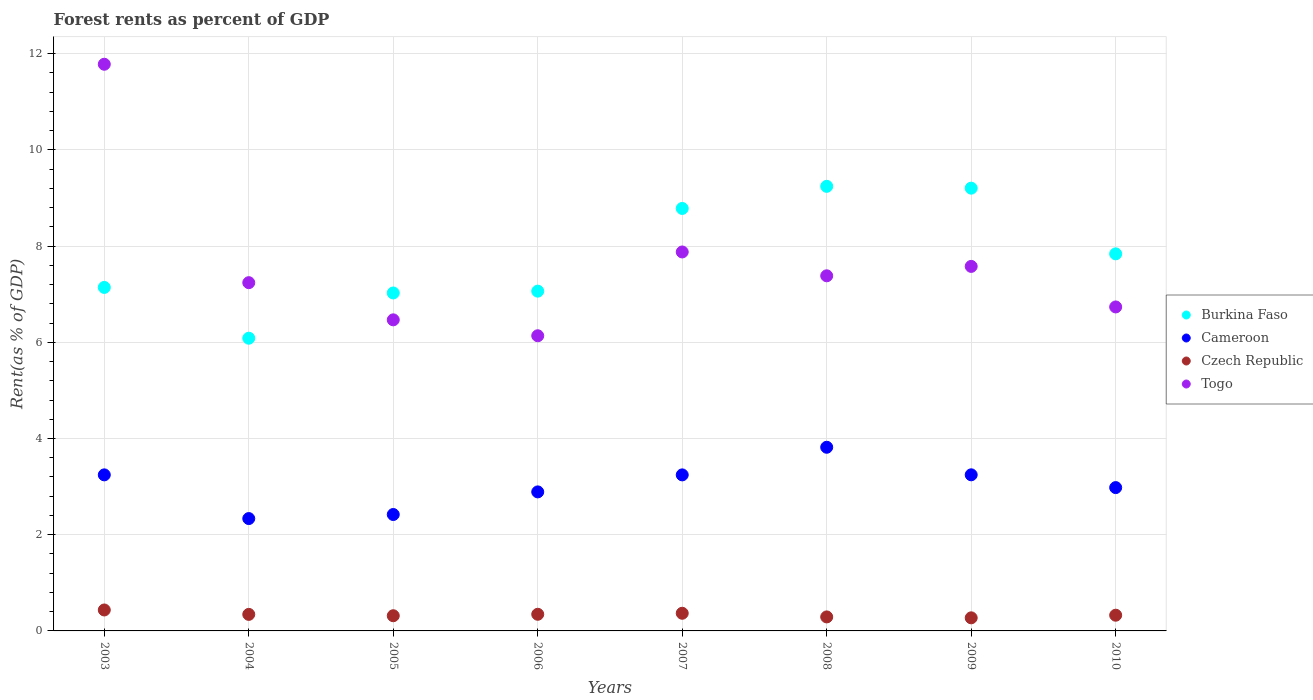What is the forest rent in Togo in 2009?
Provide a short and direct response. 7.58. Across all years, what is the maximum forest rent in Togo?
Your answer should be compact. 11.78. Across all years, what is the minimum forest rent in Cameroon?
Offer a very short reply. 2.34. What is the total forest rent in Togo in the graph?
Keep it short and to the point. 61.2. What is the difference between the forest rent in Cameroon in 2003 and that in 2005?
Ensure brevity in your answer.  0.82. What is the difference between the forest rent in Burkina Faso in 2006 and the forest rent in Cameroon in 2008?
Your response must be concise. 3.25. What is the average forest rent in Czech Republic per year?
Your answer should be compact. 0.34. In the year 2007, what is the difference between the forest rent in Czech Republic and forest rent in Cameroon?
Your response must be concise. -2.88. In how many years, is the forest rent in Burkina Faso greater than 0.4 %?
Provide a short and direct response. 8. What is the ratio of the forest rent in Togo in 2006 to that in 2008?
Provide a short and direct response. 0.83. Is the forest rent in Burkina Faso in 2004 less than that in 2007?
Provide a succinct answer. Yes. Is the difference between the forest rent in Czech Republic in 2006 and 2008 greater than the difference between the forest rent in Cameroon in 2006 and 2008?
Keep it short and to the point. Yes. What is the difference between the highest and the second highest forest rent in Togo?
Your answer should be compact. 3.9. What is the difference between the highest and the lowest forest rent in Togo?
Your answer should be very brief. 5.64. In how many years, is the forest rent in Burkina Faso greater than the average forest rent in Burkina Faso taken over all years?
Keep it short and to the point. 4. Is it the case that in every year, the sum of the forest rent in Burkina Faso and forest rent in Cameroon  is greater than the sum of forest rent in Togo and forest rent in Czech Republic?
Ensure brevity in your answer.  Yes. Is the forest rent in Cameroon strictly less than the forest rent in Czech Republic over the years?
Offer a very short reply. No. How many dotlines are there?
Your response must be concise. 4. What is the difference between two consecutive major ticks on the Y-axis?
Provide a short and direct response. 2. Does the graph contain grids?
Your answer should be compact. Yes. How many legend labels are there?
Make the answer very short. 4. What is the title of the graph?
Your answer should be very brief. Forest rents as percent of GDP. Does "Cote d'Ivoire" appear as one of the legend labels in the graph?
Give a very brief answer. No. What is the label or title of the Y-axis?
Offer a terse response. Rent(as % of GDP). What is the Rent(as % of GDP) of Burkina Faso in 2003?
Your answer should be very brief. 7.14. What is the Rent(as % of GDP) of Cameroon in 2003?
Provide a succinct answer. 3.24. What is the Rent(as % of GDP) in Czech Republic in 2003?
Your answer should be very brief. 0.44. What is the Rent(as % of GDP) of Togo in 2003?
Your answer should be compact. 11.78. What is the Rent(as % of GDP) in Burkina Faso in 2004?
Provide a short and direct response. 6.09. What is the Rent(as % of GDP) of Cameroon in 2004?
Provide a succinct answer. 2.34. What is the Rent(as % of GDP) of Czech Republic in 2004?
Your response must be concise. 0.34. What is the Rent(as % of GDP) in Togo in 2004?
Your answer should be compact. 7.24. What is the Rent(as % of GDP) in Burkina Faso in 2005?
Provide a short and direct response. 7.03. What is the Rent(as % of GDP) of Cameroon in 2005?
Make the answer very short. 2.42. What is the Rent(as % of GDP) in Czech Republic in 2005?
Offer a very short reply. 0.32. What is the Rent(as % of GDP) of Togo in 2005?
Provide a short and direct response. 6.47. What is the Rent(as % of GDP) of Burkina Faso in 2006?
Give a very brief answer. 7.06. What is the Rent(as % of GDP) of Cameroon in 2006?
Provide a succinct answer. 2.89. What is the Rent(as % of GDP) in Czech Republic in 2006?
Give a very brief answer. 0.35. What is the Rent(as % of GDP) in Togo in 2006?
Keep it short and to the point. 6.14. What is the Rent(as % of GDP) in Burkina Faso in 2007?
Offer a very short reply. 8.78. What is the Rent(as % of GDP) in Cameroon in 2007?
Provide a succinct answer. 3.24. What is the Rent(as % of GDP) in Czech Republic in 2007?
Ensure brevity in your answer.  0.37. What is the Rent(as % of GDP) in Togo in 2007?
Offer a very short reply. 7.88. What is the Rent(as % of GDP) of Burkina Faso in 2008?
Keep it short and to the point. 9.24. What is the Rent(as % of GDP) of Cameroon in 2008?
Provide a short and direct response. 3.82. What is the Rent(as % of GDP) in Czech Republic in 2008?
Your answer should be compact. 0.29. What is the Rent(as % of GDP) in Togo in 2008?
Give a very brief answer. 7.38. What is the Rent(as % of GDP) in Burkina Faso in 2009?
Provide a short and direct response. 9.2. What is the Rent(as % of GDP) in Cameroon in 2009?
Your response must be concise. 3.25. What is the Rent(as % of GDP) of Czech Republic in 2009?
Keep it short and to the point. 0.27. What is the Rent(as % of GDP) in Togo in 2009?
Give a very brief answer. 7.58. What is the Rent(as % of GDP) of Burkina Faso in 2010?
Provide a succinct answer. 7.84. What is the Rent(as % of GDP) of Cameroon in 2010?
Keep it short and to the point. 2.98. What is the Rent(as % of GDP) of Czech Republic in 2010?
Provide a short and direct response. 0.33. What is the Rent(as % of GDP) in Togo in 2010?
Give a very brief answer. 6.74. Across all years, what is the maximum Rent(as % of GDP) in Burkina Faso?
Keep it short and to the point. 9.24. Across all years, what is the maximum Rent(as % of GDP) of Cameroon?
Your answer should be compact. 3.82. Across all years, what is the maximum Rent(as % of GDP) of Czech Republic?
Your answer should be compact. 0.44. Across all years, what is the maximum Rent(as % of GDP) of Togo?
Your answer should be compact. 11.78. Across all years, what is the minimum Rent(as % of GDP) of Burkina Faso?
Provide a short and direct response. 6.09. Across all years, what is the minimum Rent(as % of GDP) in Cameroon?
Give a very brief answer. 2.34. Across all years, what is the minimum Rent(as % of GDP) in Czech Republic?
Make the answer very short. 0.27. Across all years, what is the minimum Rent(as % of GDP) of Togo?
Your answer should be very brief. 6.14. What is the total Rent(as % of GDP) in Burkina Faso in the graph?
Provide a succinct answer. 62.38. What is the total Rent(as % of GDP) in Cameroon in the graph?
Offer a very short reply. 24.18. What is the total Rent(as % of GDP) in Czech Republic in the graph?
Your answer should be compact. 2.7. What is the total Rent(as % of GDP) in Togo in the graph?
Ensure brevity in your answer.  61.2. What is the difference between the Rent(as % of GDP) of Burkina Faso in 2003 and that in 2004?
Make the answer very short. 1.06. What is the difference between the Rent(as % of GDP) in Cameroon in 2003 and that in 2004?
Make the answer very short. 0.91. What is the difference between the Rent(as % of GDP) in Czech Republic in 2003 and that in 2004?
Your answer should be compact. 0.09. What is the difference between the Rent(as % of GDP) of Togo in 2003 and that in 2004?
Keep it short and to the point. 4.54. What is the difference between the Rent(as % of GDP) of Burkina Faso in 2003 and that in 2005?
Give a very brief answer. 0.12. What is the difference between the Rent(as % of GDP) in Cameroon in 2003 and that in 2005?
Make the answer very short. 0.82. What is the difference between the Rent(as % of GDP) in Czech Republic in 2003 and that in 2005?
Ensure brevity in your answer.  0.12. What is the difference between the Rent(as % of GDP) in Togo in 2003 and that in 2005?
Make the answer very short. 5.31. What is the difference between the Rent(as % of GDP) in Burkina Faso in 2003 and that in 2006?
Your response must be concise. 0.08. What is the difference between the Rent(as % of GDP) in Cameroon in 2003 and that in 2006?
Give a very brief answer. 0.35. What is the difference between the Rent(as % of GDP) of Czech Republic in 2003 and that in 2006?
Provide a succinct answer. 0.09. What is the difference between the Rent(as % of GDP) in Togo in 2003 and that in 2006?
Keep it short and to the point. 5.64. What is the difference between the Rent(as % of GDP) of Burkina Faso in 2003 and that in 2007?
Your response must be concise. -1.64. What is the difference between the Rent(as % of GDP) in Cameroon in 2003 and that in 2007?
Give a very brief answer. 0. What is the difference between the Rent(as % of GDP) of Czech Republic in 2003 and that in 2007?
Keep it short and to the point. 0.07. What is the difference between the Rent(as % of GDP) of Togo in 2003 and that in 2007?
Offer a very short reply. 3.9. What is the difference between the Rent(as % of GDP) of Burkina Faso in 2003 and that in 2008?
Ensure brevity in your answer.  -2.1. What is the difference between the Rent(as % of GDP) of Cameroon in 2003 and that in 2008?
Your answer should be compact. -0.57. What is the difference between the Rent(as % of GDP) in Czech Republic in 2003 and that in 2008?
Your answer should be compact. 0.14. What is the difference between the Rent(as % of GDP) in Togo in 2003 and that in 2008?
Your response must be concise. 4.4. What is the difference between the Rent(as % of GDP) in Burkina Faso in 2003 and that in 2009?
Give a very brief answer. -2.06. What is the difference between the Rent(as % of GDP) in Cameroon in 2003 and that in 2009?
Provide a short and direct response. -0. What is the difference between the Rent(as % of GDP) of Czech Republic in 2003 and that in 2009?
Provide a succinct answer. 0.16. What is the difference between the Rent(as % of GDP) in Togo in 2003 and that in 2009?
Ensure brevity in your answer.  4.2. What is the difference between the Rent(as % of GDP) of Burkina Faso in 2003 and that in 2010?
Your response must be concise. -0.7. What is the difference between the Rent(as % of GDP) in Cameroon in 2003 and that in 2010?
Provide a short and direct response. 0.26. What is the difference between the Rent(as % of GDP) of Czech Republic in 2003 and that in 2010?
Your answer should be compact. 0.11. What is the difference between the Rent(as % of GDP) of Togo in 2003 and that in 2010?
Keep it short and to the point. 5.05. What is the difference between the Rent(as % of GDP) of Burkina Faso in 2004 and that in 2005?
Ensure brevity in your answer.  -0.94. What is the difference between the Rent(as % of GDP) of Cameroon in 2004 and that in 2005?
Provide a succinct answer. -0.08. What is the difference between the Rent(as % of GDP) of Czech Republic in 2004 and that in 2005?
Your response must be concise. 0.03. What is the difference between the Rent(as % of GDP) in Togo in 2004 and that in 2005?
Offer a terse response. 0.77. What is the difference between the Rent(as % of GDP) in Burkina Faso in 2004 and that in 2006?
Make the answer very short. -0.98. What is the difference between the Rent(as % of GDP) of Cameroon in 2004 and that in 2006?
Give a very brief answer. -0.55. What is the difference between the Rent(as % of GDP) of Czech Republic in 2004 and that in 2006?
Provide a succinct answer. -0. What is the difference between the Rent(as % of GDP) in Togo in 2004 and that in 2006?
Provide a short and direct response. 1.1. What is the difference between the Rent(as % of GDP) of Burkina Faso in 2004 and that in 2007?
Offer a terse response. -2.7. What is the difference between the Rent(as % of GDP) of Cameroon in 2004 and that in 2007?
Offer a very short reply. -0.91. What is the difference between the Rent(as % of GDP) in Czech Republic in 2004 and that in 2007?
Keep it short and to the point. -0.02. What is the difference between the Rent(as % of GDP) of Togo in 2004 and that in 2007?
Your answer should be compact. -0.64. What is the difference between the Rent(as % of GDP) in Burkina Faso in 2004 and that in 2008?
Keep it short and to the point. -3.16. What is the difference between the Rent(as % of GDP) of Cameroon in 2004 and that in 2008?
Your answer should be very brief. -1.48. What is the difference between the Rent(as % of GDP) of Czech Republic in 2004 and that in 2008?
Give a very brief answer. 0.05. What is the difference between the Rent(as % of GDP) in Togo in 2004 and that in 2008?
Offer a terse response. -0.14. What is the difference between the Rent(as % of GDP) in Burkina Faso in 2004 and that in 2009?
Your response must be concise. -3.12. What is the difference between the Rent(as % of GDP) of Cameroon in 2004 and that in 2009?
Ensure brevity in your answer.  -0.91. What is the difference between the Rent(as % of GDP) in Czech Republic in 2004 and that in 2009?
Your answer should be compact. 0.07. What is the difference between the Rent(as % of GDP) in Togo in 2004 and that in 2009?
Provide a succinct answer. -0.34. What is the difference between the Rent(as % of GDP) in Burkina Faso in 2004 and that in 2010?
Offer a very short reply. -1.75. What is the difference between the Rent(as % of GDP) in Cameroon in 2004 and that in 2010?
Provide a succinct answer. -0.64. What is the difference between the Rent(as % of GDP) of Czech Republic in 2004 and that in 2010?
Keep it short and to the point. 0.02. What is the difference between the Rent(as % of GDP) in Togo in 2004 and that in 2010?
Give a very brief answer. 0.5. What is the difference between the Rent(as % of GDP) of Burkina Faso in 2005 and that in 2006?
Keep it short and to the point. -0.04. What is the difference between the Rent(as % of GDP) in Cameroon in 2005 and that in 2006?
Keep it short and to the point. -0.47. What is the difference between the Rent(as % of GDP) of Czech Republic in 2005 and that in 2006?
Offer a terse response. -0.03. What is the difference between the Rent(as % of GDP) of Togo in 2005 and that in 2006?
Your response must be concise. 0.33. What is the difference between the Rent(as % of GDP) in Burkina Faso in 2005 and that in 2007?
Offer a terse response. -1.76. What is the difference between the Rent(as % of GDP) of Cameroon in 2005 and that in 2007?
Ensure brevity in your answer.  -0.82. What is the difference between the Rent(as % of GDP) of Czech Republic in 2005 and that in 2007?
Ensure brevity in your answer.  -0.05. What is the difference between the Rent(as % of GDP) in Togo in 2005 and that in 2007?
Your response must be concise. -1.41. What is the difference between the Rent(as % of GDP) of Burkina Faso in 2005 and that in 2008?
Your response must be concise. -2.22. What is the difference between the Rent(as % of GDP) of Cameroon in 2005 and that in 2008?
Offer a terse response. -1.4. What is the difference between the Rent(as % of GDP) of Czech Republic in 2005 and that in 2008?
Keep it short and to the point. 0.02. What is the difference between the Rent(as % of GDP) in Togo in 2005 and that in 2008?
Your response must be concise. -0.92. What is the difference between the Rent(as % of GDP) in Burkina Faso in 2005 and that in 2009?
Your response must be concise. -2.18. What is the difference between the Rent(as % of GDP) of Cameroon in 2005 and that in 2009?
Keep it short and to the point. -0.83. What is the difference between the Rent(as % of GDP) of Czech Republic in 2005 and that in 2009?
Your answer should be very brief. 0.04. What is the difference between the Rent(as % of GDP) in Togo in 2005 and that in 2009?
Make the answer very short. -1.11. What is the difference between the Rent(as % of GDP) in Burkina Faso in 2005 and that in 2010?
Keep it short and to the point. -0.81. What is the difference between the Rent(as % of GDP) of Cameroon in 2005 and that in 2010?
Keep it short and to the point. -0.56. What is the difference between the Rent(as % of GDP) in Czech Republic in 2005 and that in 2010?
Ensure brevity in your answer.  -0.01. What is the difference between the Rent(as % of GDP) in Togo in 2005 and that in 2010?
Provide a short and direct response. -0.27. What is the difference between the Rent(as % of GDP) in Burkina Faso in 2006 and that in 2007?
Your answer should be very brief. -1.72. What is the difference between the Rent(as % of GDP) of Cameroon in 2006 and that in 2007?
Provide a succinct answer. -0.35. What is the difference between the Rent(as % of GDP) of Czech Republic in 2006 and that in 2007?
Keep it short and to the point. -0.02. What is the difference between the Rent(as % of GDP) of Togo in 2006 and that in 2007?
Your answer should be very brief. -1.74. What is the difference between the Rent(as % of GDP) in Burkina Faso in 2006 and that in 2008?
Offer a very short reply. -2.18. What is the difference between the Rent(as % of GDP) in Cameroon in 2006 and that in 2008?
Keep it short and to the point. -0.93. What is the difference between the Rent(as % of GDP) in Czech Republic in 2006 and that in 2008?
Ensure brevity in your answer.  0.05. What is the difference between the Rent(as % of GDP) in Togo in 2006 and that in 2008?
Ensure brevity in your answer.  -1.25. What is the difference between the Rent(as % of GDP) in Burkina Faso in 2006 and that in 2009?
Give a very brief answer. -2.14. What is the difference between the Rent(as % of GDP) in Cameroon in 2006 and that in 2009?
Your answer should be very brief. -0.36. What is the difference between the Rent(as % of GDP) in Czech Republic in 2006 and that in 2009?
Make the answer very short. 0.07. What is the difference between the Rent(as % of GDP) of Togo in 2006 and that in 2009?
Keep it short and to the point. -1.44. What is the difference between the Rent(as % of GDP) of Burkina Faso in 2006 and that in 2010?
Keep it short and to the point. -0.78. What is the difference between the Rent(as % of GDP) in Cameroon in 2006 and that in 2010?
Keep it short and to the point. -0.09. What is the difference between the Rent(as % of GDP) in Czech Republic in 2006 and that in 2010?
Give a very brief answer. 0.02. What is the difference between the Rent(as % of GDP) in Togo in 2006 and that in 2010?
Your answer should be very brief. -0.6. What is the difference between the Rent(as % of GDP) in Burkina Faso in 2007 and that in 2008?
Offer a terse response. -0.46. What is the difference between the Rent(as % of GDP) of Cameroon in 2007 and that in 2008?
Give a very brief answer. -0.57. What is the difference between the Rent(as % of GDP) of Czech Republic in 2007 and that in 2008?
Give a very brief answer. 0.08. What is the difference between the Rent(as % of GDP) of Togo in 2007 and that in 2008?
Provide a succinct answer. 0.5. What is the difference between the Rent(as % of GDP) in Burkina Faso in 2007 and that in 2009?
Your response must be concise. -0.42. What is the difference between the Rent(as % of GDP) of Cameroon in 2007 and that in 2009?
Your response must be concise. -0. What is the difference between the Rent(as % of GDP) in Czech Republic in 2007 and that in 2009?
Give a very brief answer. 0.09. What is the difference between the Rent(as % of GDP) of Togo in 2007 and that in 2009?
Your answer should be compact. 0.3. What is the difference between the Rent(as % of GDP) in Burkina Faso in 2007 and that in 2010?
Offer a very short reply. 0.94. What is the difference between the Rent(as % of GDP) in Cameroon in 2007 and that in 2010?
Make the answer very short. 0.26. What is the difference between the Rent(as % of GDP) of Czech Republic in 2007 and that in 2010?
Offer a terse response. 0.04. What is the difference between the Rent(as % of GDP) of Togo in 2007 and that in 2010?
Provide a succinct answer. 1.14. What is the difference between the Rent(as % of GDP) of Burkina Faso in 2008 and that in 2009?
Your answer should be compact. 0.04. What is the difference between the Rent(as % of GDP) of Cameroon in 2008 and that in 2009?
Make the answer very short. 0.57. What is the difference between the Rent(as % of GDP) in Czech Republic in 2008 and that in 2009?
Offer a very short reply. 0.02. What is the difference between the Rent(as % of GDP) of Togo in 2008 and that in 2009?
Your answer should be very brief. -0.2. What is the difference between the Rent(as % of GDP) of Burkina Faso in 2008 and that in 2010?
Ensure brevity in your answer.  1.4. What is the difference between the Rent(as % of GDP) in Cameroon in 2008 and that in 2010?
Make the answer very short. 0.84. What is the difference between the Rent(as % of GDP) in Czech Republic in 2008 and that in 2010?
Offer a very short reply. -0.04. What is the difference between the Rent(as % of GDP) of Togo in 2008 and that in 2010?
Offer a terse response. 0.65. What is the difference between the Rent(as % of GDP) of Burkina Faso in 2009 and that in 2010?
Provide a succinct answer. 1.37. What is the difference between the Rent(as % of GDP) of Cameroon in 2009 and that in 2010?
Make the answer very short. 0.27. What is the difference between the Rent(as % of GDP) in Czech Republic in 2009 and that in 2010?
Give a very brief answer. -0.05. What is the difference between the Rent(as % of GDP) of Togo in 2009 and that in 2010?
Offer a very short reply. 0.84. What is the difference between the Rent(as % of GDP) in Burkina Faso in 2003 and the Rent(as % of GDP) in Cameroon in 2004?
Your response must be concise. 4.81. What is the difference between the Rent(as % of GDP) in Burkina Faso in 2003 and the Rent(as % of GDP) in Czech Republic in 2004?
Offer a very short reply. 6.8. What is the difference between the Rent(as % of GDP) in Burkina Faso in 2003 and the Rent(as % of GDP) in Togo in 2004?
Offer a terse response. -0.1. What is the difference between the Rent(as % of GDP) in Cameroon in 2003 and the Rent(as % of GDP) in Czech Republic in 2004?
Keep it short and to the point. 2.9. What is the difference between the Rent(as % of GDP) of Cameroon in 2003 and the Rent(as % of GDP) of Togo in 2004?
Provide a succinct answer. -4. What is the difference between the Rent(as % of GDP) in Czech Republic in 2003 and the Rent(as % of GDP) in Togo in 2004?
Provide a short and direct response. -6.8. What is the difference between the Rent(as % of GDP) of Burkina Faso in 2003 and the Rent(as % of GDP) of Cameroon in 2005?
Offer a terse response. 4.72. What is the difference between the Rent(as % of GDP) of Burkina Faso in 2003 and the Rent(as % of GDP) of Czech Republic in 2005?
Your answer should be very brief. 6.83. What is the difference between the Rent(as % of GDP) of Burkina Faso in 2003 and the Rent(as % of GDP) of Togo in 2005?
Give a very brief answer. 0.67. What is the difference between the Rent(as % of GDP) of Cameroon in 2003 and the Rent(as % of GDP) of Czech Republic in 2005?
Offer a terse response. 2.93. What is the difference between the Rent(as % of GDP) in Cameroon in 2003 and the Rent(as % of GDP) in Togo in 2005?
Offer a terse response. -3.22. What is the difference between the Rent(as % of GDP) in Czech Republic in 2003 and the Rent(as % of GDP) in Togo in 2005?
Your answer should be compact. -6.03. What is the difference between the Rent(as % of GDP) of Burkina Faso in 2003 and the Rent(as % of GDP) of Cameroon in 2006?
Give a very brief answer. 4.25. What is the difference between the Rent(as % of GDP) of Burkina Faso in 2003 and the Rent(as % of GDP) of Czech Republic in 2006?
Your answer should be compact. 6.8. What is the difference between the Rent(as % of GDP) in Cameroon in 2003 and the Rent(as % of GDP) in Czech Republic in 2006?
Offer a very short reply. 2.9. What is the difference between the Rent(as % of GDP) in Cameroon in 2003 and the Rent(as % of GDP) in Togo in 2006?
Your answer should be compact. -2.89. What is the difference between the Rent(as % of GDP) in Czech Republic in 2003 and the Rent(as % of GDP) in Togo in 2006?
Ensure brevity in your answer.  -5.7. What is the difference between the Rent(as % of GDP) of Burkina Faso in 2003 and the Rent(as % of GDP) of Cameroon in 2007?
Your answer should be very brief. 3.9. What is the difference between the Rent(as % of GDP) in Burkina Faso in 2003 and the Rent(as % of GDP) in Czech Republic in 2007?
Provide a short and direct response. 6.77. What is the difference between the Rent(as % of GDP) in Burkina Faso in 2003 and the Rent(as % of GDP) in Togo in 2007?
Offer a very short reply. -0.74. What is the difference between the Rent(as % of GDP) of Cameroon in 2003 and the Rent(as % of GDP) of Czech Republic in 2007?
Your answer should be very brief. 2.88. What is the difference between the Rent(as % of GDP) in Cameroon in 2003 and the Rent(as % of GDP) in Togo in 2007?
Ensure brevity in your answer.  -4.63. What is the difference between the Rent(as % of GDP) in Czech Republic in 2003 and the Rent(as % of GDP) in Togo in 2007?
Provide a succinct answer. -7.44. What is the difference between the Rent(as % of GDP) of Burkina Faso in 2003 and the Rent(as % of GDP) of Cameroon in 2008?
Offer a very short reply. 3.32. What is the difference between the Rent(as % of GDP) in Burkina Faso in 2003 and the Rent(as % of GDP) in Czech Republic in 2008?
Your response must be concise. 6.85. What is the difference between the Rent(as % of GDP) of Burkina Faso in 2003 and the Rent(as % of GDP) of Togo in 2008?
Make the answer very short. -0.24. What is the difference between the Rent(as % of GDP) of Cameroon in 2003 and the Rent(as % of GDP) of Czech Republic in 2008?
Ensure brevity in your answer.  2.95. What is the difference between the Rent(as % of GDP) of Cameroon in 2003 and the Rent(as % of GDP) of Togo in 2008?
Make the answer very short. -4.14. What is the difference between the Rent(as % of GDP) in Czech Republic in 2003 and the Rent(as % of GDP) in Togo in 2008?
Give a very brief answer. -6.95. What is the difference between the Rent(as % of GDP) of Burkina Faso in 2003 and the Rent(as % of GDP) of Cameroon in 2009?
Ensure brevity in your answer.  3.9. What is the difference between the Rent(as % of GDP) in Burkina Faso in 2003 and the Rent(as % of GDP) in Czech Republic in 2009?
Offer a very short reply. 6.87. What is the difference between the Rent(as % of GDP) of Burkina Faso in 2003 and the Rent(as % of GDP) of Togo in 2009?
Provide a succinct answer. -0.44. What is the difference between the Rent(as % of GDP) in Cameroon in 2003 and the Rent(as % of GDP) in Czech Republic in 2009?
Give a very brief answer. 2.97. What is the difference between the Rent(as % of GDP) of Cameroon in 2003 and the Rent(as % of GDP) of Togo in 2009?
Keep it short and to the point. -4.33. What is the difference between the Rent(as % of GDP) in Czech Republic in 2003 and the Rent(as % of GDP) in Togo in 2009?
Provide a succinct answer. -7.14. What is the difference between the Rent(as % of GDP) in Burkina Faso in 2003 and the Rent(as % of GDP) in Cameroon in 2010?
Your answer should be very brief. 4.16. What is the difference between the Rent(as % of GDP) in Burkina Faso in 2003 and the Rent(as % of GDP) in Czech Republic in 2010?
Provide a short and direct response. 6.81. What is the difference between the Rent(as % of GDP) in Burkina Faso in 2003 and the Rent(as % of GDP) in Togo in 2010?
Your response must be concise. 0.41. What is the difference between the Rent(as % of GDP) in Cameroon in 2003 and the Rent(as % of GDP) in Czech Republic in 2010?
Provide a succinct answer. 2.92. What is the difference between the Rent(as % of GDP) of Cameroon in 2003 and the Rent(as % of GDP) of Togo in 2010?
Offer a very short reply. -3.49. What is the difference between the Rent(as % of GDP) in Czech Republic in 2003 and the Rent(as % of GDP) in Togo in 2010?
Give a very brief answer. -6.3. What is the difference between the Rent(as % of GDP) in Burkina Faso in 2004 and the Rent(as % of GDP) in Cameroon in 2005?
Ensure brevity in your answer.  3.67. What is the difference between the Rent(as % of GDP) in Burkina Faso in 2004 and the Rent(as % of GDP) in Czech Republic in 2005?
Your answer should be very brief. 5.77. What is the difference between the Rent(as % of GDP) in Burkina Faso in 2004 and the Rent(as % of GDP) in Togo in 2005?
Ensure brevity in your answer.  -0.38. What is the difference between the Rent(as % of GDP) of Cameroon in 2004 and the Rent(as % of GDP) of Czech Republic in 2005?
Your response must be concise. 2.02. What is the difference between the Rent(as % of GDP) of Cameroon in 2004 and the Rent(as % of GDP) of Togo in 2005?
Your answer should be compact. -4.13. What is the difference between the Rent(as % of GDP) in Czech Republic in 2004 and the Rent(as % of GDP) in Togo in 2005?
Keep it short and to the point. -6.12. What is the difference between the Rent(as % of GDP) in Burkina Faso in 2004 and the Rent(as % of GDP) in Cameroon in 2006?
Keep it short and to the point. 3.19. What is the difference between the Rent(as % of GDP) of Burkina Faso in 2004 and the Rent(as % of GDP) of Czech Republic in 2006?
Ensure brevity in your answer.  5.74. What is the difference between the Rent(as % of GDP) in Burkina Faso in 2004 and the Rent(as % of GDP) in Togo in 2006?
Your answer should be compact. -0.05. What is the difference between the Rent(as % of GDP) in Cameroon in 2004 and the Rent(as % of GDP) in Czech Republic in 2006?
Make the answer very short. 1.99. What is the difference between the Rent(as % of GDP) in Cameroon in 2004 and the Rent(as % of GDP) in Togo in 2006?
Provide a succinct answer. -3.8. What is the difference between the Rent(as % of GDP) in Czech Republic in 2004 and the Rent(as % of GDP) in Togo in 2006?
Ensure brevity in your answer.  -5.79. What is the difference between the Rent(as % of GDP) in Burkina Faso in 2004 and the Rent(as % of GDP) in Cameroon in 2007?
Keep it short and to the point. 2.84. What is the difference between the Rent(as % of GDP) in Burkina Faso in 2004 and the Rent(as % of GDP) in Czech Republic in 2007?
Keep it short and to the point. 5.72. What is the difference between the Rent(as % of GDP) of Burkina Faso in 2004 and the Rent(as % of GDP) of Togo in 2007?
Make the answer very short. -1.79. What is the difference between the Rent(as % of GDP) of Cameroon in 2004 and the Rent(as % of GDP) of Czech Republic in 2007?
Your answer should be compact. 1.97. What is the difference between the Rent(as % of GDP) in Cameroon in 2004 and the Rent(as % of GDP) in Togo in 2007?
Make the answer very short. -5.54. What is the difference between the Rent(as % of GDP) of Czech Republic in 2004 and the Rent(as % of GDP) of Togo in 2007?
Provide a short and direct response. -7.53. What is the difference between the Rent(as % of GDP) of Burkina Faso in 2004 and the Rent(as % of GDP) of Cameroon in 2008?
Your response must be concise. 2.27. What is the difference between the Rent(as % of GDP) in Burkina Faso in 2004 and the Rent(as % of GDP) in Czech Republic in 2008?
Keep it short and to the point. 5.79. What is the difference between the Rent(as % of GDP) of Burkina Faso in 2004 and the Rent(as % of GDP) of Togo in 2008?
Give a very brief answer. -1.3. What is the difference between the Rent(as % of GDP) of Cameroon in 2004 and the Rent(as % of GDP) of Czech Republic in 2008?
Offer a very short reply. 2.04. What is the difference between the Rent(as % of GDP) of Cameroon in 2004 and the Rent(as % of GDP) of Togo in 2008?
Keep it short and to the point. -5.05. What is the difference between the Rent(as % of GDP) of Czech Republic in 2004 and the Rent(as % of GDP) of Togo in 2008?
Your answer should be compact. -7.04. What is the difference between the Rent(as % of GDP) of Burkina Faso in 2004 and the Rent(as % of GDP) of Cameroon in 2009?
Provide a short and direct response. 2.84. What is the difference between the Rent(as % of GDP) of Burkina Faso in 2004 and the Rent(as % of GDP) of Czech Republic in 2009?
Your answer should be compact. 5.81. What is the difference between the Rent(as % of GDP) in Burkina Faso in 2004 and the Rent(as % of GDP) in Togo in 2009?
Ensure brevity in your answer.  -1.49. What is the difference between the Rent(as % of GDP) in Cameroon in 2004 and the Rent(as % of GDP) in Czech Republic in 2009?
Make the answer very short. 2.06. What is the difference between the Rent(as % of GDP) of Cameroon in 2004 and the Rent(as % of GDP) of Togo in 2009?
Your answer should be compact. -5.24. What is the difference between the Rent(as % of GDP) of Czech Republic in 2004 and the Rent(as % of GDP) of Togo in 2009?
Keep it short and to the point. -7.23. What is the difference between the Rent(as % of GDP) in Burkina Faso in 2004 and the Rent(as % of GDP) in Cameroon in 2010?
Offer a very short reply. 3.11. What is the difference between the Rent(as % of GDP) in Burkina Faso in 2004 and the Rent(as % of GDP) in Czech Republic in 2010?
Offer a terse response. 5.76. What is the difference between the Rent(as % of GDP) in Burkina Faso in 2004 and the Rent(as % of GDP) in Togo in 2010?
Give a very brief answer. -0.65. What is the difference between the Rent(as % of GDP) in Cameroon in 2004 and the Rent(as % of GDP) in Czech Republic in 2010?
Your response must be concise. 2.01. What is the difference between the Rent(as % of GDP) in Cameroon in 2004 and the Rent(as % of GDP) in Togo in 2010?
Offer a terse response. -4.4. What is the difference between the Rent(as % of GDP) in Czech Republic in 2004 and the Rent(as % of GDP) in Togo in 2010?
Keep it short and to the point. -6.39. What is the difference between the Rent(as % of GDP) in Burkina Faso in 2005 and the Rent(as % of GDP) in Cameroon in 2006?
Your response must be concise. 4.14. What is the difference between the Rent(as % of GDP) of Burkina Faso in 2005 and the Rent(as % of GDP) of Czech Republic in 2006?
Offer a terse response. 6.68. What is the difference between the Rent(as % of GDP) in Burkina Faso in 2005 and the Rent(as % of GDP) in Togo in 2006?
Make the answer very short. 0.89. What is the difference between the Rent(as % of GDP) of Cameroon in 2005 and the Rent(as % of GDP) of Czech Republic in 2006?
Provide a succinct answer. 2.07. What is the difference between the Rent(as % of GDP) in Cameroon in 2005 and the Rent(as % of GDP) in Togo in 2006?
Offer a very short reply. -3.72. What is the difference between the Rent(as % of GDP) in Czech Republic in 2005 and the Rent(as % of GDP) in Togo in 2006?
Provide a succinct answer. -5.82. What is the difference between the Rent(as % of GDP) in Burkina Faso in 2005 and the Rent(as % of GDP) in Cameroon in 2007?
Provide a succinct answer. 3.78. What is the difference between the Rent(as % of GDP) of Burkina Faso in 2005 and the Rent(as % of GDP) of Czech Republic in 2007?
Give a very brief answer. 6.66. What is the difference between the Rent(as % of GDP) of Burkina Faso in 2005 and the Rent(as % of GDP) of Togo in 2007?
Make the answer very short. -0.85. What is the difference between the Rent(as % of GDP) in Cameroon in 2005 and the Rent(as % of GDP) in Czech Republic in 2007?
Make the answer very short. 2.05. What is the difference between the Rent(as % of GDP) of Cameroon in 2005 and the Rent(as % of GDP) of Togo in 2007?
Ensure brevity in your answer.  -5.46. What is the difference between the Rent(as % of GDP) in Czech Republic in 2005 and the Rent(as % of GDP) in Togo in 2007?
Offer a very short reply. -7.56. What is the difference between the Rent(as % of GDP) of Burkina Faso in 2005 and the Rent(as % of GDP) of Cameroon in 2008?
Your answer should be compact. 3.21. What is the difference between the Rent(as % of GDP) of Burkina Faso in 2005 and the Rent(as % of GDP) of Czech Republic in 2008?
Ensure brevity in your answer.  6.73. What is the difference between the Rent(as % of GDP) in Burkina Faso in 2005 and the Rent(as % of GDP) in Togo in 2008?
Your response must be concise. -0.36. What is the difference between the Rent(as % of GDP) in Cameroon in 2005 and the Rent(as % of GDP) in Czech Republic in 2008?
Offer a terse response. 2.13. What is the difference between the Rent(as % of GDP) in Cameroon in 2005 and the Rent(as % of GDP) in Togo in 2008?
Provide a short and direct response. -4.96. What is the difference between the Rent(as % of GDP) of Czech Republic in 2005 and the Rent(as % of GDP) of Togo in 2008?
Your answer should be compact. -7.07. What is the difference between the Rent(as % of GDP) of Burkina Faso in 2005 and the Rent(as % of GDP) of Cameroon in 2009?
Provide a short and direct response. 3.78. What is the difference between the Rent(as % of GDP) of Burkina Faso in 2005 and the Rent(as % of GDP) of Czech Republic in 2009?
Give a very brief answer. 6.75. What is the difference between the Rent(as % of GDP) in Burkina Faso in 2005 and the Rent(as % of GDP) in Togo in 2009?
Provide a short and direct response. -0.55. What is the difference between the Rent(as % of GDP) of Cameroon in 2005 and the Rent(as % of GDP) of Czech Republic in 2009?
Your answer should be very brief. 2.15. What is the difference between the Rent(as % of GDP) in Cameroon in 2005 and the Rent(as % of GDP) in Togo in 2009?
Ensure brevity in your answer.  -5.16. What is the difference between the Rent(as % of GDP) of Czech Republic in 2005 and the Rent(as % of GDP) of Togo in 2009?
Your response must be concise. -7.26. What is the difference between the Rent(as % of GDP) in Burkina Faso in 2005 and the Rent(as % of GDP) in Cameroon in 2010?
Your answer should be very brief. 4.05. What is the difference between the Rent(as % of GDP) of Burkina Faso in 2005 and the Rent(as % of GDP) of Czech Republic in 2010?
Your answer should be very brief. 6.7. What is the difference between the Rent(as % of GDP) in Burkina Faso in 2005 and the Rent(as % of GDP) in Togo in 2010?
Your answer should be very brief. 0.29. What is the difference between the Rent(as % of GDP) in Cameroon in 2005 and the Rent(as % of GDP) in Czech Republic in 2010?
Give a very brief answer. 2.09. What is the difference between the Rent(as % of GDP) of Cameroon in 2005 and the Rent(as % of GDP) of Togo in 2010?
Your response must be concise. -4.31. What is the difference between the Rent(as % of GDP) of Czech Republic in 2005 and the Rent(as % of GDP) of Togo in 2010?
Your answer should be compact. -6.42. What is the difference between the Rent(as % of GDP) in Burkina Faso in 2006 and the Rent(as % of GDP) in Cameroon in 2007?
Your answer should be very brief. 3.82. What is the difference between the Rent(as % of GDP) in Burkina Faso in 2006 and the Rent(as % of GDP) in Czech Republic in 2007?
Keep it short and to the point. 6.7. What is the difference between the Rent(as % of GDP) in Burkina Faso in 2006 and the Rent(as % of GDP) in Togo in 2007?
Make the answer very short. -0.81. What is the difference between the Rent(as % of GDP) of Cameroon in 2006 and the Rent(as % of GDP) of Czech Republic in 2007?
Your response must be concise. 2.52. What is the difference between the Rent(as % of GDP) of Cameroon in 2006 and the Rent(as % of GDP) of Togo in 2007?
Make the answer very short. -4.99. What is the difference between the Rent(as % of GDP) in Czech Republic in 2006 and the Rent(as % of GDP) in Togo in 2007?
Your response must be concise. -7.53. What is the difference between the Rent(as % of GDP) of Burkina Faso in 2006 and the Rent(as % of GDP) of Cameroon in 2008?
Your answer should be very brief. 3.25. What is the difference between the Rent(as % of GDP) of Burkina Faso in 2006 and the Rent(as % of GDP) of Czech Republic in 2008?
Your answer should be very brief. 6.77. What is the difference between the Rent(as % of GDP) of Burkina Faso in 2006 and the Rent(as % of GDP) of Togo in 2008?
Offer a terse response. -0.32. What is the difference between the Rent(as % of GDP) in Cameroon in 2006 and the Rent(as % of GDP) in Czech Republic in 2008?
Provide a succinct answer. 2.6. What is the difference between the Rent(as % of GDP) of Cameroon in 2006 and the Rent(as % of GDP) of Togo in 2008?
Provide a short and direct response. -4.49. What is the difference between the Rent(as % of GDP) in Czech Republic in 2006 and the Rent(as % of GDP) in Togo in 2008?
Make the answer very short. -7.04. What is the difference between the Rent(as % of GDP) in Burkina Faso in 2006 and the Rent(as % of GDP) in Cameroon in 2009?
Offer a very short reply. 3.82. What is the difference between the Rent(as % of GDP) of Burkina Faso in 2006 and the Rent(as % of GDP) of Czech Republic in 2009?
Provide a short and direct response. 6.79. What is the difference between the Rent(as % of GDP) in Burkina Faso in 2006 and the Rent(as % of GDP) in Togo in 2009?
Provide a succinct answer. -0.51. What is the difference between the Rent(as % of GDP) in Cameroon in 2006 and the Rent(as % of GDP) in Czech Republic in 2009?
Keep it short and to the point. 2.62. What is the difference between the Rent(as % of GDP) in Cameroon in 2006 and the Rent(as % of GDP) in Togo in 2009?
Give a very brief answer. -4.69. What is the difference between the Rent(as % of GDP) of Czech Republic in 2006 and the Rent(as % of GDP) of Togo in 2009?
Ensure brevity in your answer.  -7.23. What is the difference between the Rent(as % of GDP) in Burkina Faso in 2006 and the Rent(as % of GDP) in Cameroon in 2010?
Your response must be concise. 4.08. What is the difference between the Rent(as % of GDP) in Burkina Faso in 2006 and the Rent(as % of GDP) in Czech Republic in 2010?
Make the answer very short. 6.74. What is the difference between the Rent(as % of GDP) of Burkina Faso in 2006 and the Rent(as % of GDP) of Togo in 2010?
Provide a succinct answer. 0.33. What is the difference between the Rent(as % of GDP) of Cameroon in 2006 and the Rent(as % of GDP) of Czech Republic in 2010?
Your answer should be very brief. 2.56. What is the difference between the Rent(as % of GDP) of Cameroon in 2006 and the Rent(as % of GDP) of Togo in 2010?
Keep it short and to the point. -3.84. What is the difference between the Rent(as % of GDP) of Czech Republic in 2006 and the Rent(as % of GDP) of Togo in 2010?
Provide a short and direct response. -6.39. What is the difference between the Rent(as % of GDP) in Burkina Faso in 2007 and the Rent(as % of GDP) in Cameroon in 2008?
Offer a very short reply. 4.96. What is the difference between the Rent(as % of GDP) in Burkina Faso in 2007 and the Rent(as % of GDP) in Czech Republic in 2008?
Keep it short and to the point. 8.49. What is the difference between the Rent(as % of GDP) in Burkina Faso in 2007 and the Rent(as % of GDP) in Togo in 2008?
Make the answer very short. 1.4. What is the difference between the Rent(as % of GDP) in Cameroon in 2007 and the Rent(as % of GDP) in Czech Republic in 2008?
Offer a terse response. 2.95. What is the difference between the Rent(as % of GDP) in Cameroon in 2007 and the Rent(as % of GDP) in Togo in 2008?
Offer a very short reply. -4.14. What is the difference between the Rent(as % of GDP) in Czech Republic in 2007 and the Rent(as % of GDP) in Togo in 2008?
Your answer should be very brief. -7.02. What is the difference between the Rent(as % of GDP) in Burkina Faso in 2007 and the Rent(as % of GDP) in Cameroon in 2009?
Offer a terse response. 5.54. What is the difference between the Rent(as % of GDP) in Burkina Faso in 2007 and the Rent(as % of GDP) in Czech Republic in 2009?
Provide a short and direct response. 8.51. What is the difference between the Rent(as % of GDP) in Burkina Faso in 2007 and the Rent(as % of GDP) in Togo in 2009?
Your answer should be very brief. 1.2. What is the difference between the Rent(as % of GDP) in Cameroon in 2007 and the Rent(as % of GDP) in Czech Republic in 2009?
Provide a short and direct response. 2.97. What is the difference between the Rent(as % of GDP) in Cameroon in 2007 and the Rent(as % of GDP) in Togo in 2009?
Keep it short and to the point. -4.33. What is the difference between the Rent(as % of GDP) of Czech Republic in 2007 and the Rent(as % of GDP) of Togo in 2009?
Your answer should be compact. -7.21. What is the difference between the Rent(as % of GDP) in Burkina Faso in 2007 and the Rent(as % of GDP) in Cameroon in 2010?
Your response must be concise. 5.8. What is the difference between the Rent(as % of GDP) of Burkina Faso in 2007 and the Rent(as % of GDP) of Czech Republic in 2010?
Make the answer very short. 8.46. What is the difference between the Rent(as % of GDP) in Burkina Faso in 2007 and the Rent(as % of GDP) in Togo in 2010?
Ensure brevity in your answer.  2.05. What is the difference between the Rent(as % of GDP) in Cameroon in 2007 and the Rent(as % of GDP) in Czech Republic in 2010?
Your answer should be compact. 2.92. What is the difference between the Rent(as % of GDP) in Cameroon in 2007 and the Rent(as % of GDP) in Togo in 2010?
Your response must be concise. -3.49. What is the difference between the Rent(as % of GDP) in Czech Republic in 2007 and the Rent(as % of GDP) in Togo in 2010?
Your answer should be very brief. -6.37. What is the difference between the Rent(as % of GDP) in Burkina Faso in 2008 and the Rent(as % of GDP) in Cameroon in 2009?
Give a very brief answer. 6. What is the difference between the Rent(as % of GDP) of Burkina Faso in 2008 and the Rent(as % of GDP) of Czech Republic in 2009?
Offer a very short reply. 8.97. What is the difference between the Rent(as % of GDP) of Burkina Faso in 2008 and the Rent(as % of GDP) of Togo in 2009?
Offer a very short reply. 1.66. What is the difference between the Rent(as % of GDP) of Cameroon in 2008 and the Rent(as % of GDP) of Czech Republic in 2009?
Ensure brevity in your answer.  3.55. What is the difference between the Rent(as % of GDP) in Cameroon in 2008 and the Rent(as % of GDP) in Togo in 2009?
Ensure brevity in your answer.  -3.76. What is the difference between the Rent(as % of GDP) of Czech Republic in 2008 and the Rent(as % of GDP) of Togo in 2009?
Your answer should be compact. -7.29. What is the difference between the Rent(as % of GDP) of Burkina Faso in 2008 and the Rent(as % of GDP) of Cameroon in 2010?
Provide a succinct answer. 6.26. What is the difference between the Rent(as % of GDP) of Burkina Faso in 2008 and the Rent(as % of GDP) of Czech Republic in 2010?
Your answer should be compact. 8.92. What is the difference between the Rent(as % of GDP) in Burkina Faso in 2008 and the Rent(as % of GDP) in Togo in 2010?
Provide a short and direct response. 2.51. What is the difference between the Rent(as % of GDP) in Cameroon in 2008 and the Rent(as % of GDP) in Czech Republic in 2010?
Ensure brevity in your answer.  3.49. What is the difference between the Rent(as % of GDP) in Cameroon in 2008 and the Rent(as % of GDP) in Togo in 2010?
Make the answer very short. -2.92. What is the difference between the Rent(as % of GDP) of Czech Republic in 2008 and the Rent(as % of GDP) of Togo in 2010?
Your response must be concise. -6.44. What is the difference between the Rent(as % of GDP) of Burkina Faso in 2009 and the Rent(as % of GDP) of Cameroon in 2010?
Keep it short and to the point. 6.22. What is the difference between the Rent(as % of GDP) of Burkina Faso in 2009 and the Rent(as % of GDP) of Czech Republic in 2010?
Ensure brevity in your answer.  8.88. What is the difference between the Rent(as % of GDP) of Burkina Faso in 2009 and the Rent(as % of GDP) of Togo in 2010?
Keep it short and to the point. 2.47. What is the difference between the Rent(as % of GDP) of Cameroon in 2009 and the Rent(as % of GDP) of Czech Republic in 2010?
Ensure brevity in your answer.  2.92. What is the difference between the Rent(as % of GDP) in Cameroon in 2009 and the Rent(as % of GDP) in Togo in 2010?
Provide a short and direct response. -3.49. What is the difference between the Rent(as % of GDP) of Czech Republic in 2009 and the Rent(as % of GDP) of Togo in 2010?
Ensure brevity in your answer.  -6.46. What is the average Rent(as % of GDP) of Burkina Faso per year?
Your answer should be compact. 7.8. What is the average Rent(as % of GDP) of Cameroon per year?
Offer a very short reply. 3.02. What is the average Rent(as % of GDP) in Czech Republic per year?
Give a very brief answer. 0.34. What is the average Rent(as % of GDP) of Togo per year?
Your response must be concise. 7.65. In the year 2003, what is the difference between the Rent(as % of GDP) of Burkina Faso and Rent(as % of GDP) of Cameroon?
Ensure brevity in your answer.  3.9. In the year 2003, what is the difference between the Rent(as % of GDP) in Burkina Faso and Rent(as % of GDP) in Czech Republic?
Give a very brief answer. 6.71. In the year 2003, what is the difference between the Rent(as % of GDP) of Burkina Faso and Rent(as % of GDP) of Togo?
Your response must be concise. -4.64. In the year 2003, what is the difference between the Rent(as % of GDP) of Cameroon and Rent(as % of GDP) of Czech Republic?
Offer a very short reply. 2.81. In the year 2003, what is the difference between the Rent(as % of GDP) in Cameroon and Rent(as % of GDP) in Togo?
Make the answer very short. -8.54. In the year 2003, what is the difference between the Rent(as % of GDP) in Czech Republic and Rent(as % of GDP) in Togo?
Keep it short and to the point. -11.35. In the year 2004, what is the difference between the Rent(as % of GDP) of Burkina Faso and Rent(as % of GDP) of Cameroon?
Keep it short and to the point. 3.75. In the year 2004, what is the difference between the Rent(as % of GDP) in Burkina Faso and Rent(as % of GDP) in Czech Republic?
Offer a very short reply. 5.74. In the year 2004, what is the difference between the Rent(as % of GDP) in Burkina Faso and Rent(as % of GDP) in Togo?
Make the answer very short. -1.15. In the year 2004, what is the difference between the Rent(as % of GDP) in Cameroon and Rent(as % of GDP) in Czech Republic?
Give a very brief answer. 1.99. In the year 2004, what is the difference between the Rent(as % of GDP) in Cameroon and Rent(as % of GDP) in Togo?
Offer a very short reply. -4.9. In the year 2004, what is the difference between the Rent(as % of GDP) of Czech Republic and Rent(as % of GDP) of Togo?
Provide a succinct answer. -6.9. In the year 2005, what is the difference between the Rent(as % of GDP) of Burkina Faso and Rent(as % of GDP) of Cameroon?
Keep it short and to the point. 4.61. In the year 2005, what is the difference between the Rent(as % of GDP) of Burkina Faso and Rent(as % of GDP) of Czech Republic?
Your response must be concise. 6.71. In the year 2005, what is the difference between the Rent(as % of GDP) in Burkina Faso and Rent(as % of GDP) in Togo?
Keep it short and to the point. 0.56. In the year 2005, what is the difference between the Rent(as % of GDP) in Cameroon and Rent(as % of GDP) in Czech Republic?
Give a very brief answer. 2.1. In the year 2005, what is the difference between the Rent(as % of GDP) of Cameroon and Rent(as % of GDP) of Togo?
Make the answer very short. -4.05. In the year 2005, what is the difference between the Rent(as % of GDP) in Czech Republic and Rent(as % of GDP) in Togo?
Ensure brevity in your answer.  -6.15. In the year 2006, what is the difference between the Rent(as % of GDP) in Burkina Faso and Rent(as % of GDP) in Cameroon?
Your answer should be very brief. 4.17. In the year 2006, what is the difference between the Rent(as % of GDP) in Burkina Faso and Rent(as % of GDP) in Czech Republic?
Make the answer very short. 6.72. In the year 2006, what is the difference between the Rent(as % of GDP) of Burkina Faso and Rent(as % of GDP) of Togo?
Make the answer very short. 0.93. In the year 2006, what is the difference between the Rent(as % of GDP) of Cameroon and Rent(as % of GDP) of Czech Republic?
Your answer should be compact. 2.54. In the year 2006, what is the difference between the Rent(as % of GDP) in Cameroon and Rent(as % of GDP) in Togo?
Offer a terse response. -3.25. In the year 2006, what is the difference between the Rent(as % of GDP) in Czech Republic and Rent(as % of GDP) in Togo?
Your response must be concise. -5.79. In the year 2007, what is the difference between the Rent(as % of GDP) of Burkina Faso and Rent(as % of GDP) of Cameroon?
Your response must be concise. 5.54. In the year 2007, what is the difference between the Rent(as % of GDP) of Burkina Faso and Rent(as % of GDP) of Czech Republic?
Keep it short and to the point. 8.42. In the year 2007, what is the difference between the Rent(as % of GDP) of Burkina Faso and Rent(as % of GDP) of Togo?
Give a very brief answer. 0.9. In the year 2007, what is the difference between the Rent(as % of GDP) in Cameroon and Rent(as % of GDP) in Czech Republic?
Your answer should be very brief. 2.88. In the year 2007, what is the difference between the Rent(as % of GDP) in Cameroon and Rent(as % of GDP) in Togo?
Offer a very short reply. -4.63. In the year 2007, what is the difference between the Rent(as % of GDP) in Czech Republic and Rent(as % of GDP) in Togo?
Your answer should be compact. -7.51. In the year 2008, what is the difference between the Rent(as % of GDP) in Burkina Faso and Rent(as % of GDP) in Cameroon?
Your answer should be very brief. 5.42. In the year 2008, what is the difference between the Rent(as % of GDP) in Burkina Faso and Rent(as % of GDP) in Czech Republic?
Give a very brief answer. 8.95. In the year 2008, what is the difference between the Rent(as % of GDP) in Burkina Faso and Rent(as % of GDP) in Togo?
Make the answer very short. 1.86. In the year 2008, what is the difference between the Rent(as % of GDP) in Cameroon and Rent(as % of GDP) in Czech Republic?
Make the answer very short. 3.53. In the year 2008, what is the difference between the Rent(as % of GDP) in Cameroon and Rent(as % of GDP) in Togo?
Provide a succinct answer. -3.56. In the year 2008, what is the difference between the Rent(as % of GDP) in Czech Republic and Rent(as % of GDP) in Togo?
Provide a succinct answer. -7.09. In the year 2009, what is the difference between the Rent(as % of GDP) in Burkina Faso and Rent(as % of GDP) in Cameroon?
Ensure brevity in your answer.  5.96. In the year 2009, what is the difference between the Rent(as % of GDP) in Burkina Faso and Rent(as % of GDP) in Czech Republic?
Your answer should be compact. 8.93. In the year 2009, what is the difference between the Rent(as % of GDP) of Burkina Faso and Rent(as % of GDP) of Togo?
Provide a short and direct response. 1.63. In the year 2009, what is the difference between the Rent(as % of GDP) of Cameroon and Rent(as % of GDP) of Czech Republic?
Your answer should be compact. 2.97. In the year 2009, what is the difference between the Rent(as % of GDP) in Cameroon and Rent(as % of GDP) in Togo?
Make the answer very short. -4.33. In the year 2009, what is the difference between the Rent(as % of GDP) in Czech Republic and Rent(as % of GDP) in Togo?
Give a very brief answer. -7.31. In the year 2010, what is the difference between the Rent(as % of GDP) of Burkina Faso and Rent(as % of GDP) of Cameroon?
Keep it short and to the point. 4.86. In the year 2010, what is the difference between the Rent(as % of GDP) of Burkina Faso and Rent(as % of GDP) of Czech Republic?
Offer a terse response. 7.51. In the year 2010, what is the difference between the Rent(as % of GDP) in Burkina Faso and Rent(as % of GDP) in Togo?
Offer a very short reply. 1.1. In the year 2010, what is the difference between the Rent(as % of GDP) of Cameroon and Rent(as % of GDP) of Czech Republic?
Give a very brief answer. 2.65. In the year 2010, what is the difference between the Rent(as % of GDP) of Cameroon and Rent(as % of GDP) of Togo?
Your answer should be compact. -3.76. In the year 2010, what is the difference between the Rent(as % of GDP) in Czech Republic and Rent(as % of GDP) in Togo?
Your response must be concise. -6.41. What is the ratio of the Rent(as % of GDP) in Burkina Faso in 2003 to that in 2004?
Provide a short and direct response. 1.17. What is the ratio of the Rent(as % of GDP) in Cameroon in 2003 to that in 2004?
Make the answer very short. 1.39. What is the ratio of the Rent(as % of GDP) of Czech Republic in 2003 to that in 2004?
Provide a short and direct response. 1.27. What is the ratio of the Rent(as % of GDP) of Togo in 2003 to that in 2004?
Provide a succinct answer. 1.63. What is the ratio of the Rent(as % of GDP) of Burkina Faso in 2003 to that in 2005?
Offer a terse response. 1.02. What is the ratio of the Rent(as % of GDP) of Cameroon in 2003 to that in 2005?
Make the answer very short. 1.34. What is the ratio of the Rent(as % of GDP) of Czech Republic in 2003 to that in 2005?
Your response must be concise. 1.38. What is the ratio of the Rent(as % of GDP) of Togo in 2003 to that in 2005?
Your answer should be very brief. 1.82. What is the ratio of the Rent(as % of GDP) in Burkina Faso in 2003 to that in 2006?
Your response must be concise. 1.01. What is the ratio of the Rent(as % of GDP) in Cameroon in 2003 to that in 2006?
Your answer should be very brief. 1.12. What is the ratio of the Rent(as % of GDP) of Czech Republic in 2003 to that in 2006?
Keep it short and to the point. 1.26. What is the ratio of the Rent(as % of GDP) of Togo in 2003 to that in 2006?
Offer a terse response. 1.92. What is the ratio of the Rent(as % of GDP) in Burkina Faso in 2003 to that in 2007?
Offer a terse response. 0.81. What is the ratio of the Rent(as % of GDP) of Cameroon in 2003 to that in 2007?
Offer a very short reply. 1. What is the ratio of the Rent(as % of GDP) in Czech Republic in 2003 to that in 2007?
Provide a succinct answer. 1.19. What is the ratio of the Rent(as % of GDP) of Togo in 2003 to that in 2007?
Offer a very short reply. 1.5. What is the ratio of the Rent(as % of GDP) of Burkina Faso in 2003 to that in 2008?
Ensure brevity in your answer.  0.77. What is the ratio of the Rent(as % of GDP) of Cameroon in 2003 to that in 2008?
Provide a short and direct response. 0.85. What is the ratio of the Rent(as % of GDP) of Czech Republic in 2003 to that in 2008?
Your answer should be compact. 1.5. What is the ratio of the Rent(as % of GDP) of Togo in 2003 to that in 2008?
Your response must be concise. 1.6. What is the ratio of the Rent(as % of GDP) in Burkina Faso in 2003 to that in 2009?
Keep it short and to the point. 0.78. What is the ratio of the Rent(as % of GDP) of Cameroon in 2003 to that in 2009?
Offer a terse response. 1. What is the ratio of the Rent(as % of GDP) of Czech Republic in 2003 to that in 2009?
Offer a terse response. 1.6. What is the ratio of the Rent(as % of GDP) of Togo in 2003 to that in 2009?
Make the answer very short. 1.55. What is the ratio of the Rent(as % of GDP) of Burkina Faso in 2003 to that in 2010?
Give a very brief answer. 0.91. What is the ratio of the Rent(as % of GDP) of Cameroon in 2003 to that in 2010?
Your answer should be compact. 1.09. What is the ratio of the Rent(as % of GDP) in Czech Republic in 2003 to that in 2010?
Your answer should be compact. 1.33. What is the ratio of the Rent(as % of GDP) in Togo in 2003 to that in 2010?
Provide a short and direct response. 1.75. What is the ratio of the Rent(as % of GDP) of Burkina Faso in 2004 to that in 2005?
Provide a short and direct response. 0.87. What is the ratio of the Rent(as % of GDP) in Cameroon in 2004 to that in 2005?
Your answer should be very brief. 0.97. What is the ratio of the Rent(as % of GDP) of Czech Republic in 2004 to that in 2005?
Offer a terse response. 1.09. What is the ratio of the Rent(as % of GDP) of Togo in 2004 to that in 2005?
Keep it short and to the point. 1.12. What is the ratio of the Rent(as % of GDP) of Burkina Faso in 2004 to that in 2006?
Offer a very short reply. 0.86. What is the ratio of the Rent(as % of GDP) of Cameroon in 2004 to that in 2006?
Offer a very short reply. 0.81. What is the ratio of the Rent(as % of GDP) in Czech Republic in 2004 to that in 2006?
Your answer should be very brief. 0.99. What is the ratio of the Rent(as % of GDP) in Togo in 2004 to that in 2006?
Keep it short and to the point. 1.18. What is the ratio of the Rent(as % of GDP) in Burkina Faso in 2004 to that in 2007?
Your answer should be compact. 0.69. What is the ratio of the Rent(as % of GDP) of Cameroon in 2004 to that in 2007?
Provide a short and direct response. 0.72. What is the ratio of the Rent(as % of GDP) in Czech Republic in 2004 to that in 2007?
Offer a very short reply. 0.94. What is the ratio of the Rent(as % of GDP) of Togo in 2004 to that in 2007?
Your answer should be compact. 0.92. What is the ratio of the Rent(as % of GDP) in Burkina Faso in 2004 to that in 2008?
Give a very brief answer. 0.66. What is the ratio of the Rent(as % of GDP) of Cameroon in 2004 to that in 2008?
Provide a short and direct response. 0.61. What is the ratio of the Rent(as % of GDP) of Czech Republic in 2004 to that in 2008?
Your answer should be compact. 1.18. What is the ratio of the Rent(as % of GDP) in Togo in 2004 to that in 2008?
Provide a succinct answer. 0.98. What is the ratio of the Rent(as % of GDP) in Burkina Faso in 2004 to that in 2009?
Offer a terse response. 0.66. What is the ratio of the Rent(as % of GDP) of Cameroon in 2004 to that in 2009?
Make the answer very short. 0.72. What is the ratio of the Rent(as % of GDP) in Czech Republic in 2004 to that in 2009?
Provide a short and direct response. 1.26. What is the ratio of the Rent(as % of GDP) of Togo in 2004 to that in 2009?
Provide a succinct answer. 0.96. What is the ratio of the Rent(as % of GDP) of Burkina Faso in 2004 to that in 2010?
Give a very brief answer. 0.78. What is the ratio of the Rent(as % of GDP) in Cameroon in 2004 to that in 2010?
Your response must be concise. 0.78. What is the ratio of the Rent(as % of GDP) of Czech Republic in 2004 to that in 2010?
Offer a terse response. 1.05. What is the ratio of the Rent(as % of GDP) of Togo in 2004 to that in 2010?
Your response must be concise. 1.07. What is the ratio of the Rent(as % of GDP) of Cameroon in 2005 to that in 2006?
Ensure brevity in your answer.  0.84. What is the ratio of the Rent(as % of GDP) of Czech Republic in 2005 to that in 2006?
Your answer should be very brief. 0.91. What is the ratio of the Rent(as % of GDP) in Togo in 2005 to that in 2006?
Give a very brief answer. 1.05. What is the ratio of the Rent(as % of GDP) in Burkina Faso in 2005 to that in 2007?
Offer a very short reply. 0.8. What is the ratio of the Rent(as % of GDP) of Cameroon in 2005 to that in 2007?
Your answer should be compact. 0.75. What is the ratio of the Rent(as % of GDP) of Czech Republic in 2005 to that in 2007?
Your answer should be very brief. 0.86. What is the ratio of the Rent(as % of GDP) of Togo in 2005 to that in 2007?
Keep it short and to the point. 0.82. What is the ratio of the Rent(as % of GDP) of Burkina Faso in 2005 to that in 2008?
Your response must be concise. 0.76. What is the ratio of the Rent(as % of GDP) of Cameroon in 2005 to that in 2008?
Give a very brief answer. 0.63. What is the ratio of the Rent(as % of GDP) of Czech Republic in 2005 to that in 2008?
Provide a succinct answer. 1.08. What is the ratio of the Rent(as % of GDP) of Togo in 2005 to that in 2008?
Ensure brevity in your answer.  0.88. What is the ratio of the Rent(as % of GDP) in Burkina Faso in 2005 to that in 2009?
Make the answer very short. 0.76. What is the ratio of the Rent(as % of GDP) in Cameroon in 2005 to that in 2009?
Your answer should be very brief. 0.75. What is the ratio of the Rent(as % of GDP) of Czech Republic in 2005 to that in 2009?
Your answer should be compact. 1.16. What is the ratio of the Rent(as % of GDP) in Togo in 2005 to that in 2009?
Give a very brief answer. 0.85. What is the ratio of the Rent(as % of GDP) in Burkina Faso in 2005 to that in 2010?
Offer a very short reply. 0.9. What is the ratio of the Rent(as % of GDP) in Cameroon in 2005 to that in 2010?
Offer a terse response. 0.81. What is the ratio of the Rent(as % of GDP) of Czech Republic in 2005 to that in 2010?
Make the answer very short. 0.97. What is the ratio of the Rent(as % of GDP) in Togo in 2005 to that in 2010?
Provide a succinct answer. 0.96. What is the ratio of the Rent(as % of GDP) of Burkina Faso in 2006 to that in 2007?
Provide a succinct answer. 0.8. What is the ratio of the Rent(as % of GDP) in Cameroon in 2006 to that in 2007?
Offer a very short reply. 0.89. What is the ratio of the Rent(as % of GDP) of Czech Republic in 2006 to that in 2007?
Your response must be concise. 0.94. What is the ratio of the Rent(as % of GDP) in Togo in 2006 to that in 2007?
Your response must be concise. 0.78. What is the ratio of the Rent(as % of GDP) of Burkina Faso in 2006 to that in 2008?
Offer a very short reply. 0.76. What is the ratio of the Rent(as % of GDP) of Cameroon in 2006 to that in 2008?
Offer a very short reply. 0.76. What is the ratio of the Rent(as % of GDP) in Czech Republic in 2006 to that in 2008?
Offer a terse response. 1.19. What is the ratio of the Rent(as % of GDP) of Togo in 2006 to that in 2008?
Provide a succinct answer. 0.83. What is the ratio of the Rent(as % of GDP) of Burkina Faso in 2006 to that in 2009?
Your answer should be very brief. 0.77. What is the ratio of the Rent(as % of GDP) in Cameroon in 2006 to that in 2009?
Offer a very short reply. 0.89. What is the ratio of the Rent(as % of GDP) in Czech Republic in 2006 to that in 2009?
Your answer should be compact. 1.27. What is the ratio of the Rent(as % of GDP) in Togo in 2006 to that in 2009?
Your response must be concise. 0.81. What is the ratio of the Rent(as % of GDP) in Burkina Faso in 2006 to that in 2010?
Offer a very short reply. 0.9. What is the ratio of the Rent(as % of GDP) of Czech Republic in 2006 to that in 2010?
Offer a terse response. 1.06. What is the ratio of the Rent(as % of GDP) of Togo in 2006 to that in 2010?
Your answer should be compact. 0.91. What is the ratio of the Rent(as % of GDP) in Burkina Faso in 2007 to that in 2008?
Your answer should be compact. 0.95. What is the ratio of the Rent(as % of GDP) in Cameroon in 2007 to that in 2008?
Provide a short and direct response. 0.85. What is the ratio of the Rent(as % of GDP) in Czech Republic in 2007 to that in 2008?
Give a very brief answer. 1.26. What is the ratio of the Rent(as % of GDP) of Togo in 2007 to that in 2008?
Give a very brief answer. 1.07. What is the ratio of the Rent(as % of GDP) of Burkina Faso in 2007 to that in 2009?
Make the answer very short. 0.95. What is the ratio of the Rent(as % of GDP) in Cameroon in 2007 to that in 2009?
Your response must be concise. 1. What is the ratio of the Rent(as % of GDP) of Czech Republic in 2007 to that in 2009?
Your answer should be very brief. 1.35. What is the ratio of the Rent(as % of GDP) in Togo in 2007 to that in 2009?
Ensure brevity in your answer.  1.04. What is the ratio of the Rent(as % of GDP) of Burkina Faso in 2007 to that in 2010?
Your answer should be compact. 1.12. What is the ratio of the Rent(as % of GDP) of Cameroon in 2007 to that in 2010?
Offer a terse response. 1.09. What is the ratio of the Rent(as % of GDP) in Czech Republic in 2007 to that in 2010?
Your answer should be very brief. 1.12. What is the ratio of the Rent(as % of GDP) in Togo in 2007 to that in 2010?
Provide a short and direct response. 1.17. What is the ratio of the Rent(as % of GDP) in Burkina Faso in 2008 to that in 2009?
Ensure brevity in your answer.  1. What is the ratio of the Rent(as % of GDP) in Cameroon in 2008 to that in 2009?
Provide a succinct answer. 1.18. What is the ratio of the Rent(as % of GDP) of Czech Republic in 2008 to that in 2009?
Offer a terse response. 1.07. What is the ratio of the Rent(as % of GDP) in Togo in 2008 to that in 2009?
Provide a succinct answer. 0.97. What is the ratio of the Rent(as % of GDP) in Burkina Faso in 2008 to that in 2010?
Provide a succinct answer. 1.18. What is the ratio of the Rent(as % of GDP) of Cameroon in 2008 to that in 2010?
Make the answer very short. 1.28. What is the ratio of the Rent(as % of GDP) of Czech Republic in 2008 to that in 2010?
Make the answer very short. 0.89. What is the ratio of the Rent(as % of GDP) of Togo in 2008 to that in 2010?
Ensure brevity in your answer.  1.1. What is the ratio of the Rent(as % of GDP) of Burkina Faso in 2009 to that in 2010?
Your response must be concise. 1.17. What is the ratio of the Rent(as % of GDP) of Cameroon in 2009 to that in 2010?
Your answer should be compact. 1.09. What is the ratio of the Rent(as % of GDP) of Czech Republic in 2009 to that in 2010?
Make the answer very short. 0.83. What is the ratio of the Rent(as % of GDP) in Togo in 2009 to that in 2010?
Ensure brevity in your answer.  1.13. What is the difference between the highest and the second highest Rent(as % of GDP) of Burkina Faso?
Ensure brevity in your answer.  0.04. What is the difference between the highest and the second highest Rent(as % of GDP) in Cameroon?
Give a very brief answer. 0.57. What is the difference between the highest and the second highest Rent(as % of GDP) in Czech Republic?
Offer a terse response. 0.07. What is the difference between the highest and the second highest Rent(as % of GDP) of Togo?
Keep it short and to the point. 3.9. What is the difference between the highest and the lowest Rent(as % of GDP) in Burkina Faso?
Give a very brief answer. 3.16. What is the difference between the highest and the lowest Rent(as % of GDP) of Cameroon?
Your answer should be very brief. 1.48. What is the difference between the highest and the lowest Rent(as % of GDP) in Czech Republic?
Provide a short and direct response. 0.16. What is the difference between the highest and the lowest Rent(as % of GDP) in Togo?
Make the answer very short. 5.64. 